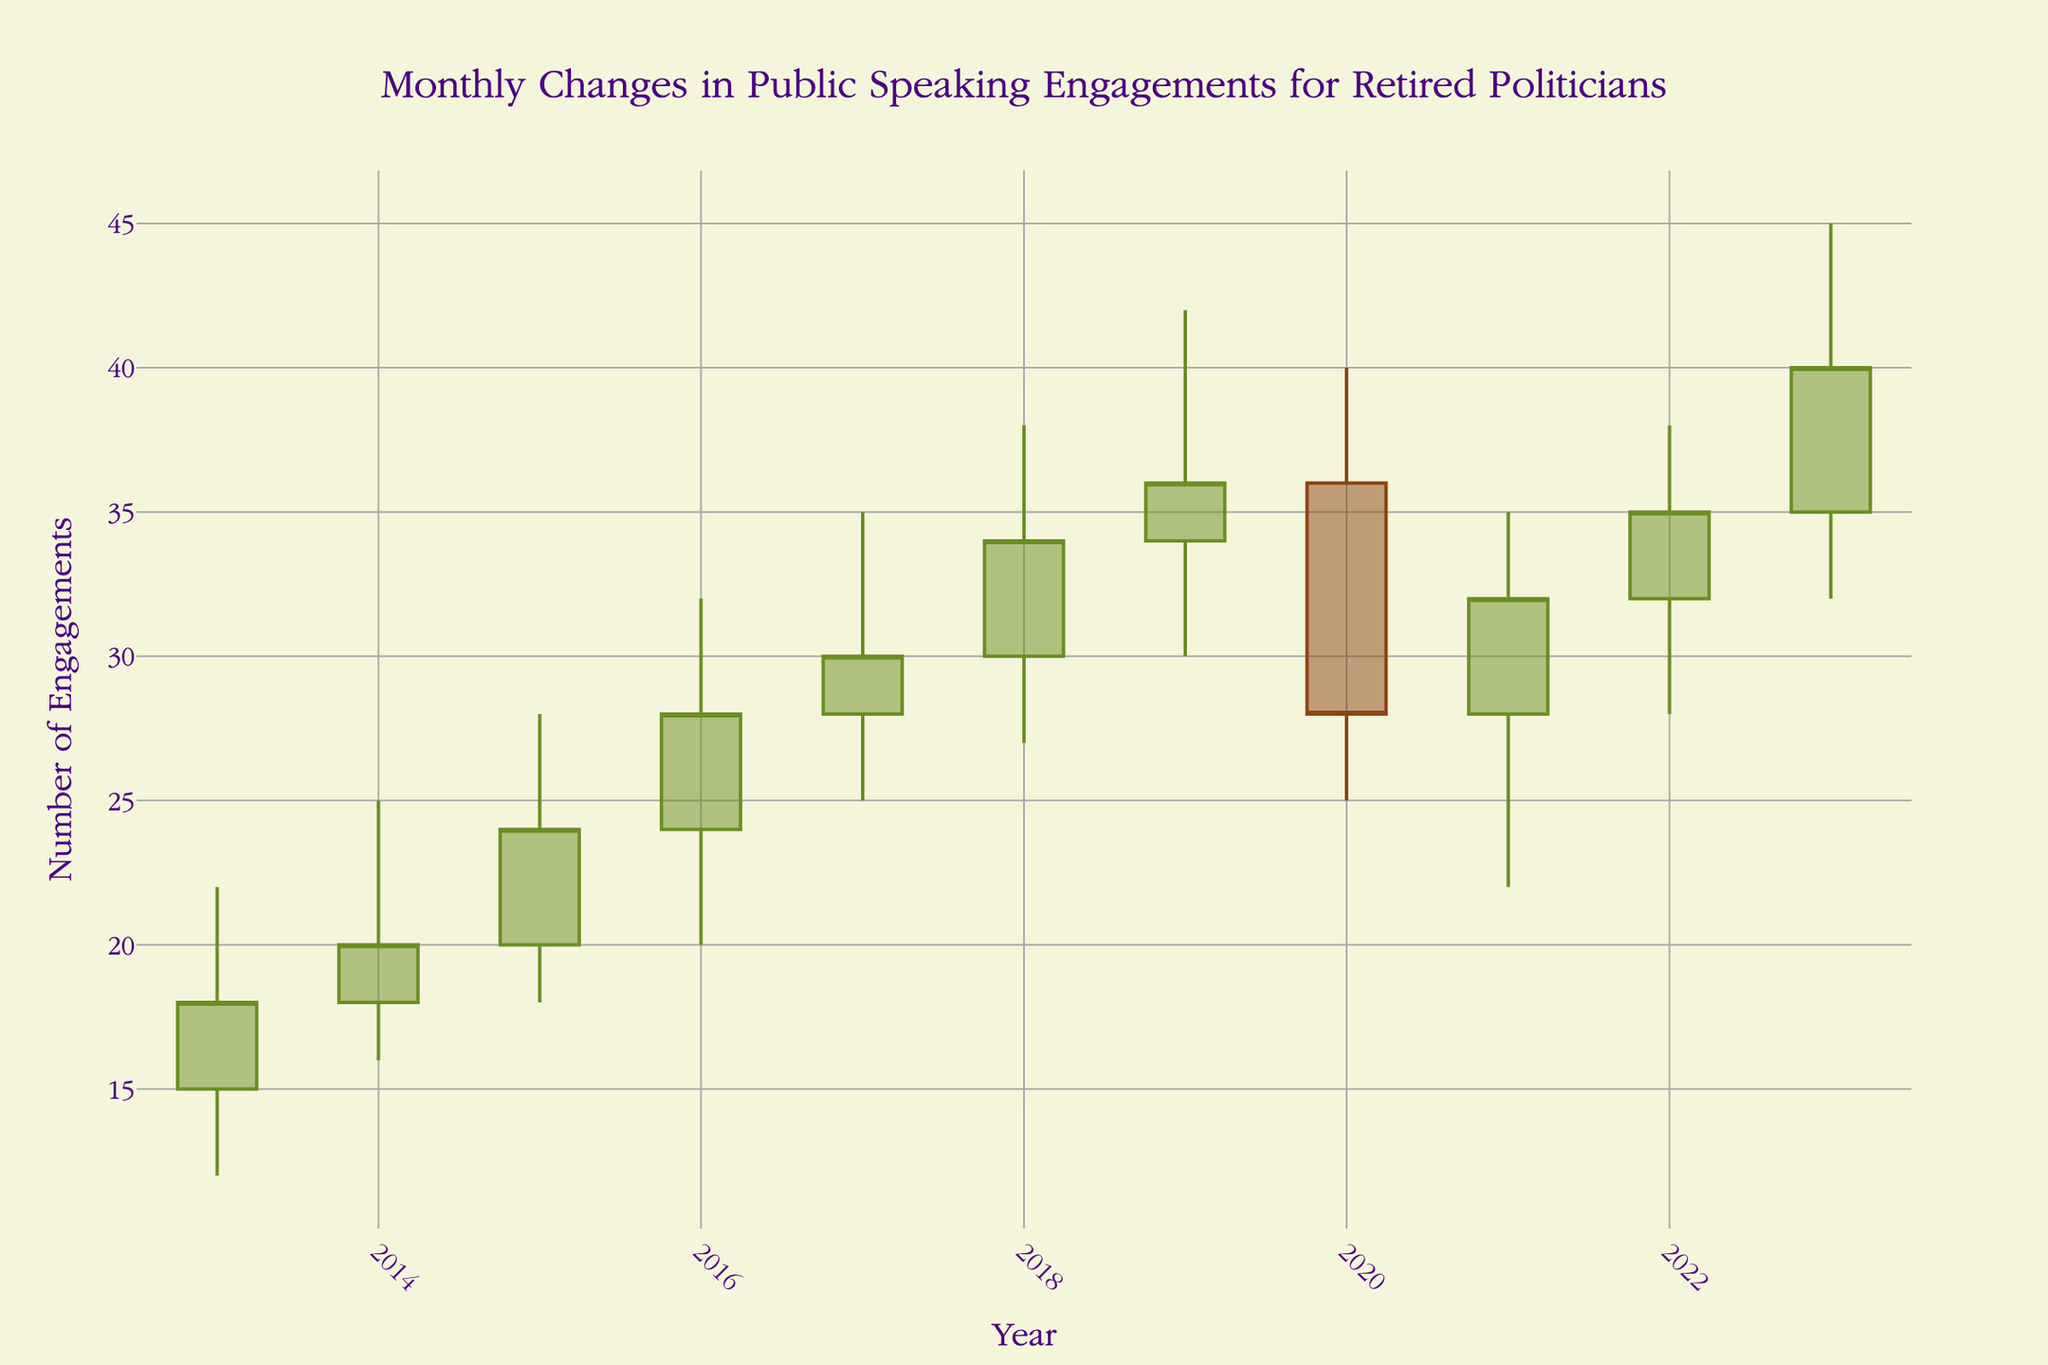How many years of data are represented in the chart? The x-axis shows yearly data points from 2013 to 2023, which totals 11 years.
Answer: 11 What's the general trend in the number of public speaking engagements from 2013 to 2023? Observing the overall movement of the OHLC candlesticks, there is a general upward trend in the data points over the decade.
Answer: Upward trend What's the highest value reached in the number of public speaking engagements, and in which year did it occur? The highest value is represented by the peak of the upper wick of the candlestick, which reaches 45. This peak occurs in 2023.
Answer: 45, 2023 Which year experienced the highest volatility in public speaking engagements? Volatility can be interpreted as the length between the high and low values within a year. In 2016, the range is from 32 to 20, giving the highest range of fluctuation of 12.
Answer: 2016 How did the number of engagements change from the end of 2019 to the end of 2020? The closing value for 2019 was 36, and for 2020, it was 28. The difference is 36 - 28 = 8, indicating a decrease of 8 engagements.
Answer: Decrease by 8 Compare the opening engagement numbers for 2013 and 2023. Which is higher, and by how much? The opening number for 2013 is 15 and for 2023 is 35. The difference is 35 - 15 = 20, indicating the opening number in 2023 is higher by 20.
Answer: 2023, by 20 Which year shows the least difference between its high and low values, indicating the least volatility? The least volatility is observed in the year with the smallest range between high and low values. For the year 2020, the high is 40 and the low is 25, yielding a range of 15 - the smallest compared to other years.
Answer: 2020 Evaluate the progression of closing values from 2013 to 2023. Are there more increases or decreases year-over-year? To assess this, we note increments or decrements between consecutive years: 2013 to 2014 (increase), 2014 to 2015 (increase), 2015 to 2016 (increase), 2016 to 2017 (increase), 2017 to 2018 (increase), 2018 to 2019 (increase), 2019 to 2020 (decrease), 2020 to 2021 (increase), 2021 to 2022 (increase), 2022 to 2023 (increase). There are 9 increases and only 1 decrease.
Answer: More increases How does the closing value in 2016 compare to its opening value that same year? In 2016, the opening value is 24, and the closing value is 28. The closing value is higher by 4 engagements.
Answer: Higher by 4 What's the average high value for the years displayed in the chart? The high values for the years are: 22, 25, 28, 32, 35, 38, 42, 40, 35, 38, 45. Summing them gives 380, and there are 11 years, so the average is 380/11 ≈ 34.55.
Answer: 34.55 